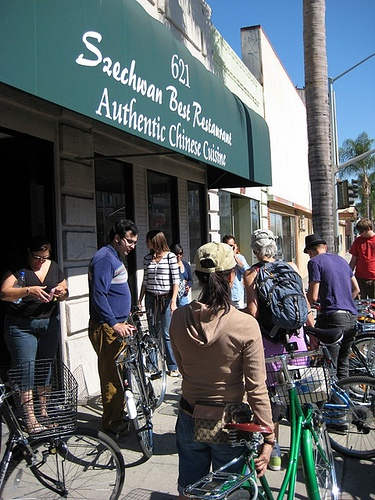Describe the objects in this image and their specific colors. I can see people in teal, black, tan, and gray tones, bicycle in teal, black, darkgray, gray, and lightgray tones, bicycle in teal, black, gray, darkgray, and lightgray tones, people in teal, black, gray, and maroon tones, and people in teal, black, blue, navy, and gray tones in this image. 